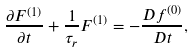<formula> <loc_0><loc_0><loc_500><loc_500>\frac { \partial { F ^ { ( 1 ) } } } { \partial { t } } + \frac { 1 } { \tau _ { r } } F ^ { ( 1 ) } = - \frac { D f ^ { ( 0 ) } } { D t } ,</formula> 